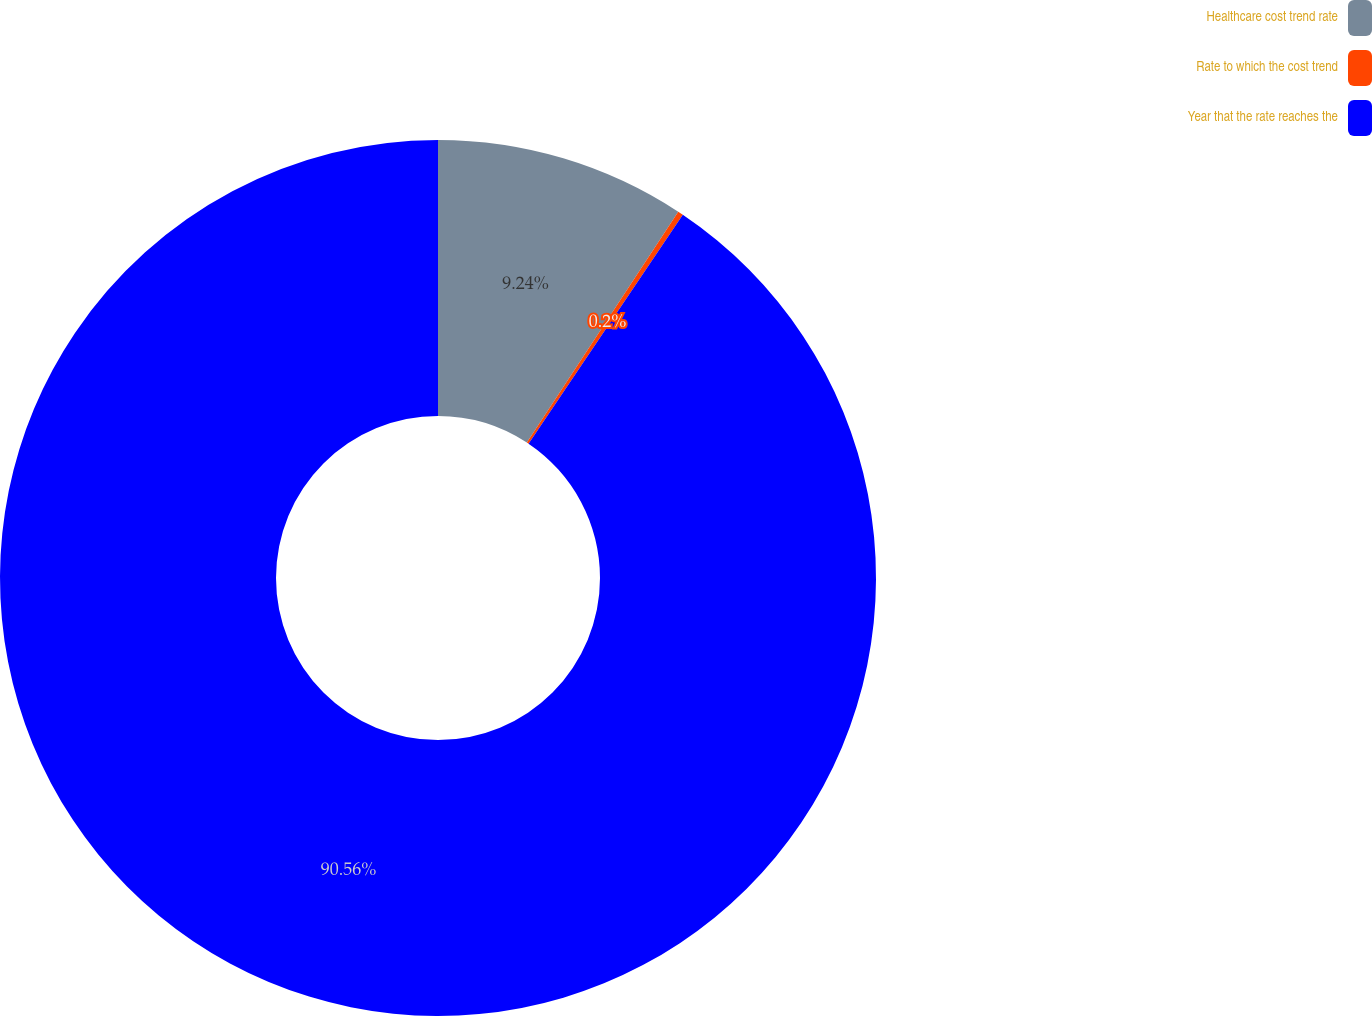<chart> <loc_0><loc_0><loc_500><loc_500><pie_chart><fcel>Healthcare cost trend rate<fcel>Rate to which the cost trend<fcel>Year that the rate reaches the<nl><fcel>9.24%<fcel>0.2%<fcel>90.56%<nl></chart> 